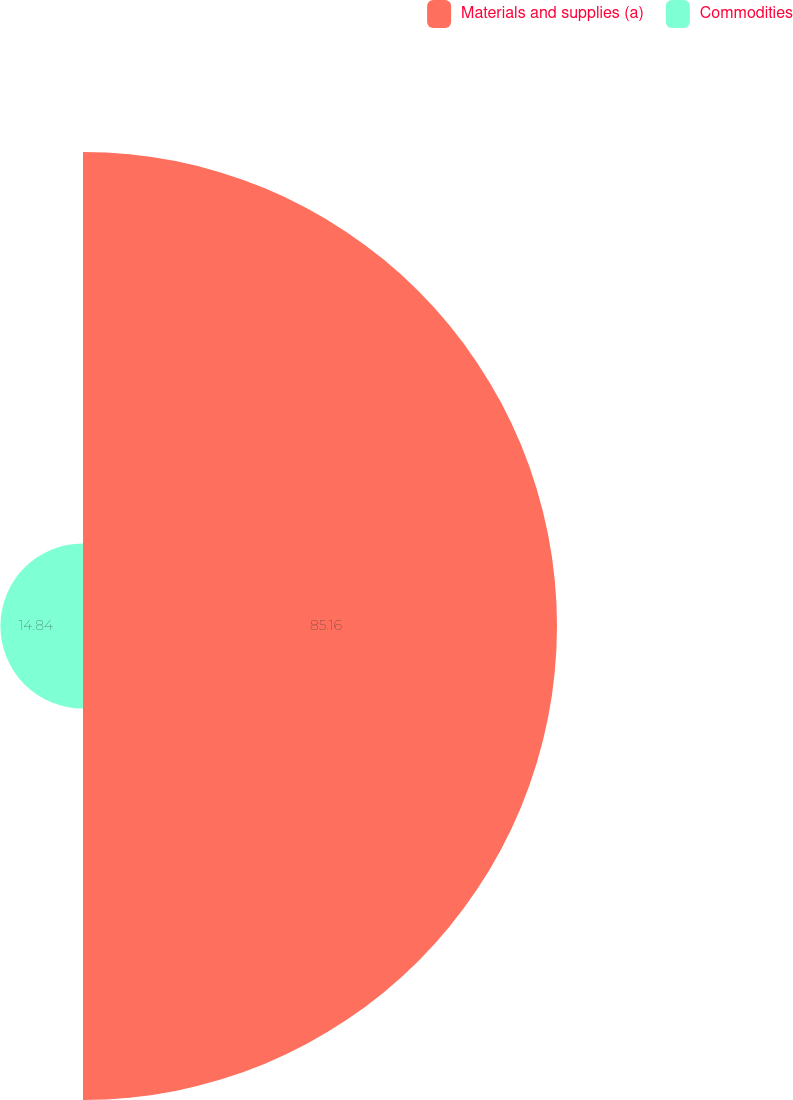Convert chart to OTSL. <chart><loc_0><loc_0><loc_500><loc_500><pie_chart><fcel>Materials and supplies (a)<fcel>Commodities<nl><fcel>85.16%<fcel>14.84%<nl></chart> 